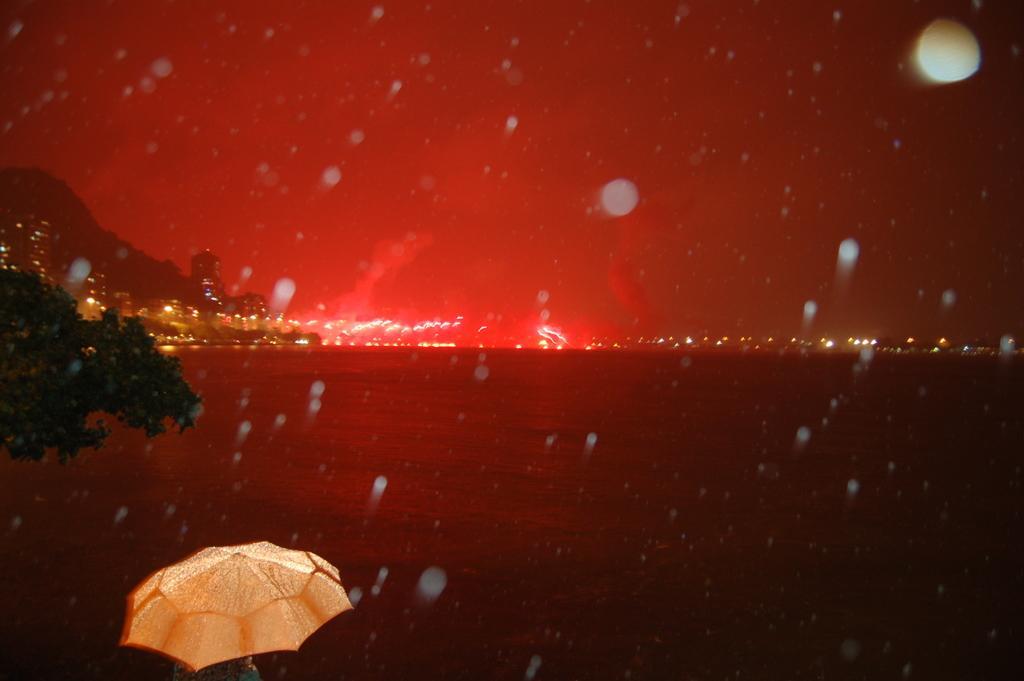In one or two sentences, can you explain what this image depicts? This is an edited image. Here we can see an umbrella, leaves, water, lights, and mountain. 